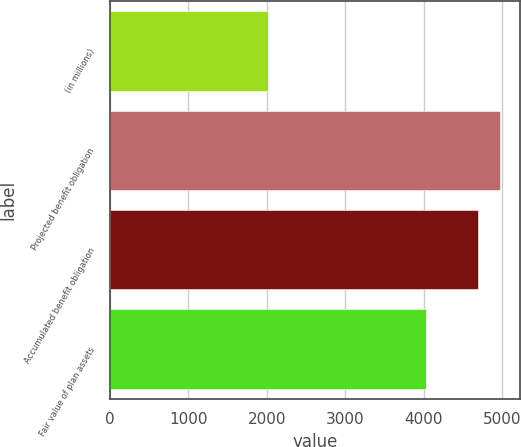Convert chart. <chart><loc_0><loc_0><loc_500><loc_500><bar_chart><fcel>(in millions)<fcel>Projected benefit obligation<fcel>Accumulated benefit obligation<fcel>Fair value of plan assets<nl><fcel>2013<fcel>4969.9<fcel>4683<fcel>4024<nl></chart> 